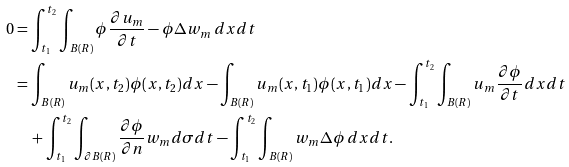Convert formula to latex. <formula><loc_0><loc_0><loc_500><loc_500>0 & = \int _ { t _ { 1 } } ^ { t _ { 2 } } \int _ { B ( R ) } \phi \frac { \partial u _ { m } } { \partial t } - \phi \Delta w _ { m } \, d x d t \\ & = \int _ { B ( R ) } u _ { m } ( x , t _ { 2 } ) \phi ( x , t _ { 2 } ) d x - \int _ { B ( R ) } u _ { m } ( x , t _ { 1 } ) \phi ( x , t _ { 1 } ) d x - \int _ { t _ { 1 } } ^ { t _ { 2 } } \int _ { B ( R ) } u _ { m } \frac { \partial \phi } { \partial t } d x d t \\ & \quad + \int _ { t _ { 1 } } ^ { t _ { 2 } } \int _ { \partial B ( R ) } \frac { \partial \phi } { \partial n } w _ { m } d \sigma d t - \int _ { t _ { 1 } } ^ { t _ { 2 } } \int _ { B ( R ) } w _ { m } \Delta \phi \, d x d t .</formula> 